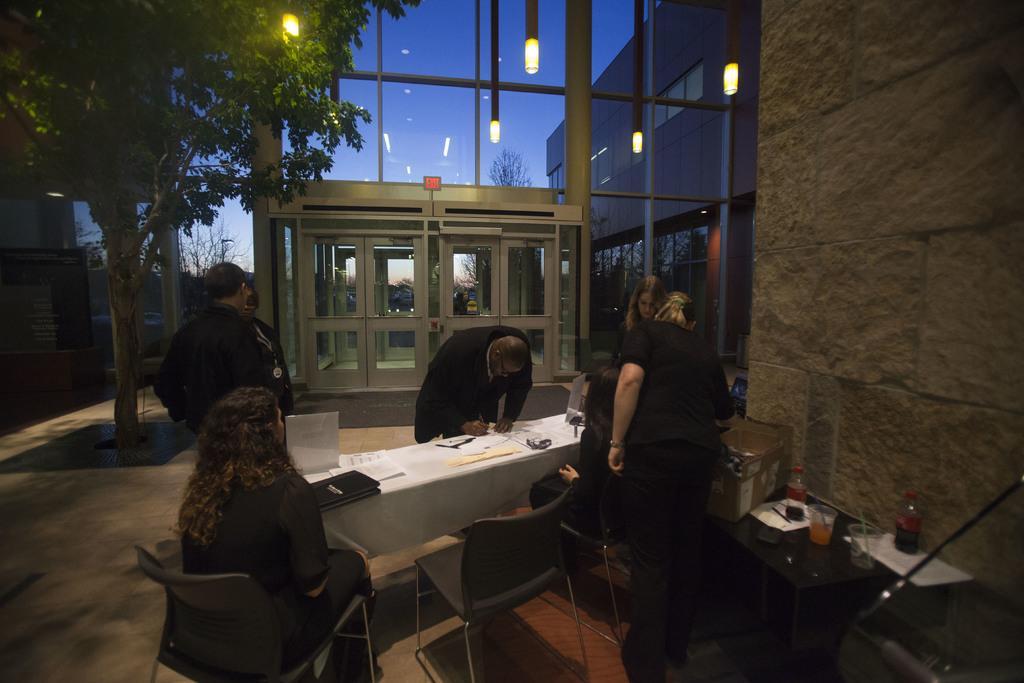Could you give a brief overview of what you see in this image? In the image there are few persons sitting around table with laptop,books,papers on it, it seems to be in an office room, over the ceiling there are lights and over the left side there is wall with table in front of it. 